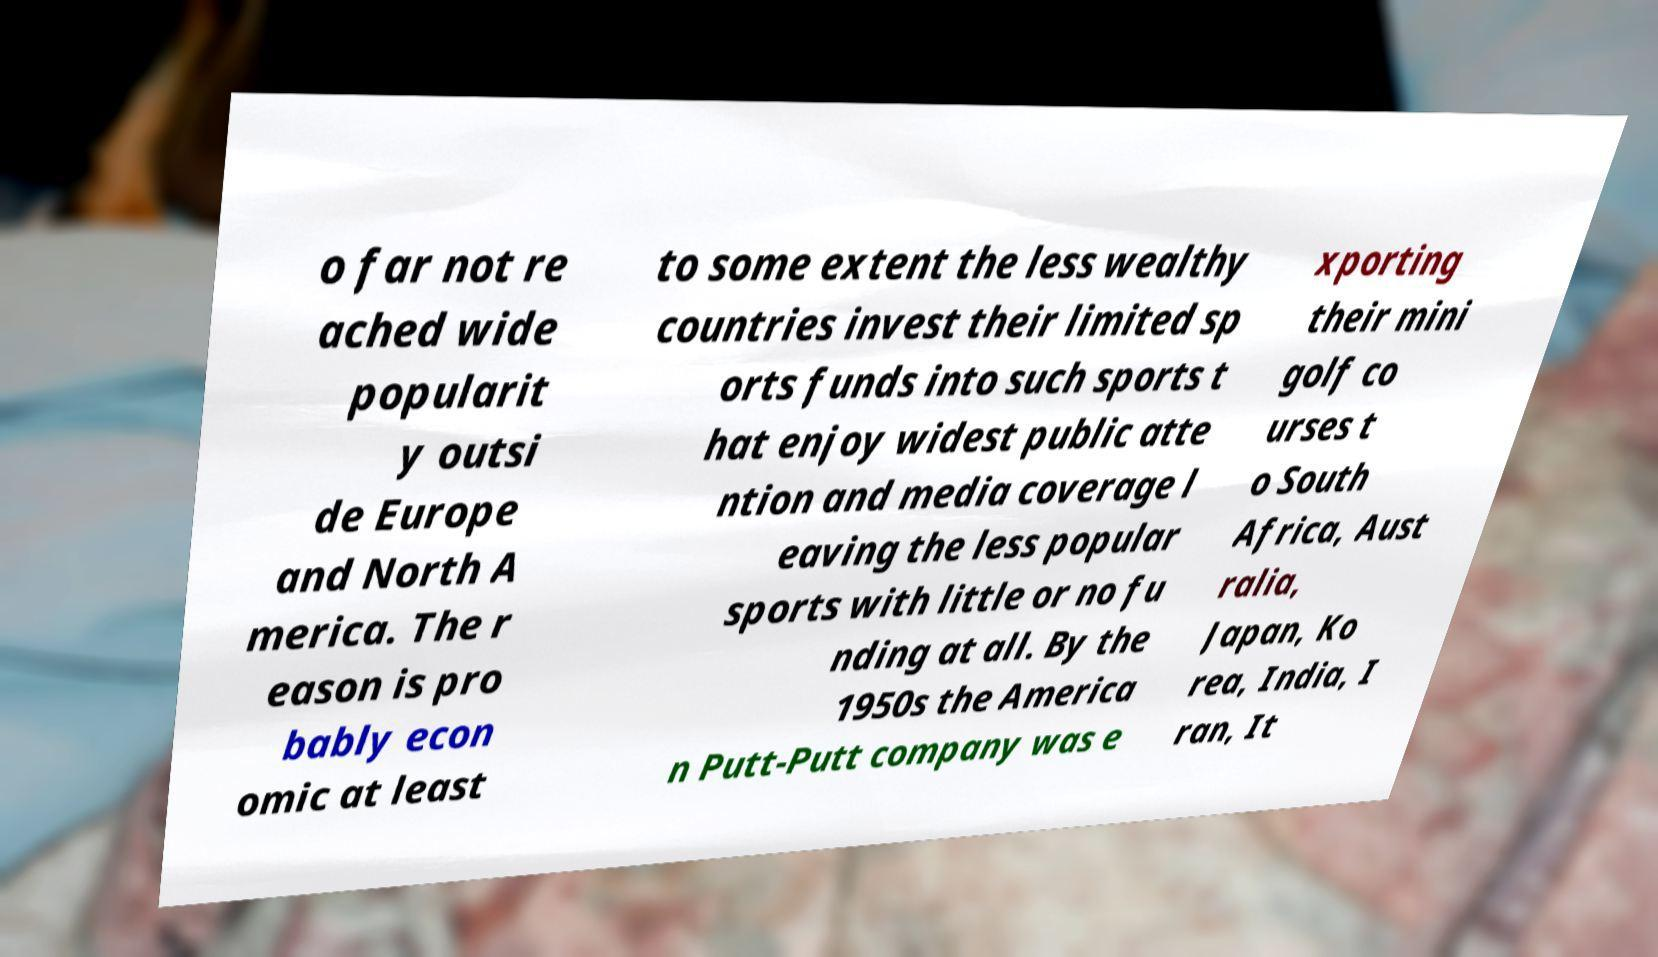Can you read and provide the text displayed in the image?This photo seems to have some interesting text. Can you extract and type it out for me? o far not re ached wide popularit y outsi de Europe and North A merica. The r eason is pro bably econ omic at least to some extent the less wealthy countries invest their limited sp orts funds into such sports t hat enjoy widest public atte ntion and media coverage l eaving the less popular sports with little or no fu nding at all. By the 1950s the America n Putt-Putt company was e xporting their mini golf co urses t o South Africa, Aust ralia, Japan, Ko rea, India, I ran, It 